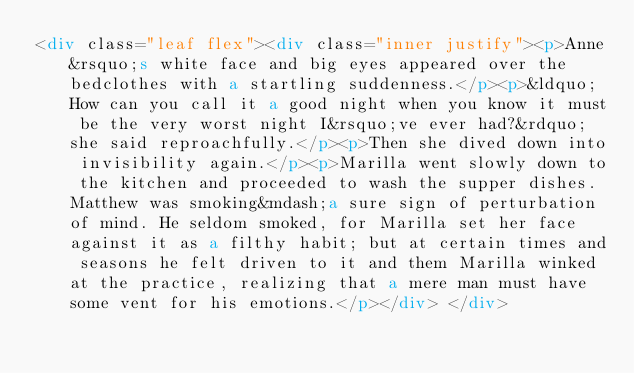Convert code to text. <code><loc_0><loc_0><loc_500><loc_500><_HTML_><div class="leaf flex"><div class="inner justify"><p>Anne&rsquo;s white face and big eyes appeared over the bedclothes with a startling suddenness.</p><p>&ldquo;How can you call it a good night when you know it must be the very worst night I&rsquo;ve ever had?&rdquo; she said reproachfully.</p><p>Then she dived down into invisibility again.</p><p>Marilla went slowly down to the kitchen and proceeded to wash the supper dishes. Matthew was smoking&mdash;a sure sign of perturbation of mind. He seldom smoked, for Marilla set her face against it as a filthy habit; but at certain times and seasons he felt driven to it and them Marilla winked at the practice, realizing that a mere man must have some vent for his emotions.</p></div> </div></code> 